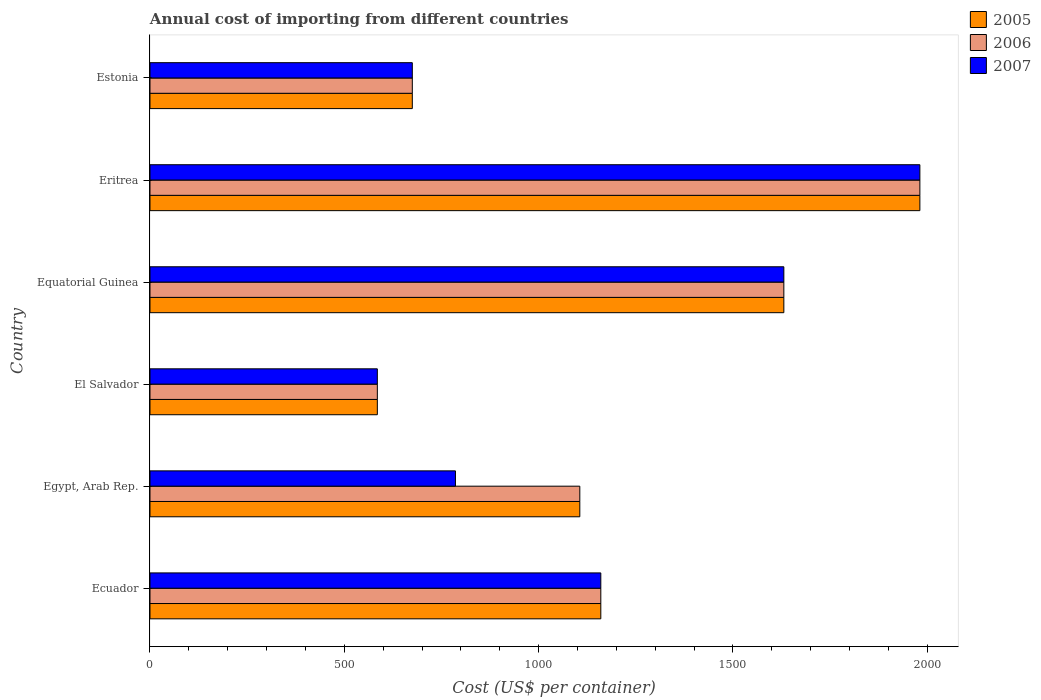How many groups of bars are there?
Give a very brief answer. 6. Are the number of bars per tick equal to the number of legend labels?
Give a very brief answer. Yes. Are the number of bars on each tick of the Y-axis equal?
Make the answer very short. Yes. What is the label of the 2nd group of bars from the top?
Your response must be concise. Eritrea. What is the total annual cost of importing in 2007 in Ecuador?
Ensure brevity in your answer.  1160. Across all countries, what is the maximum total annual cost of importing in 2006?
Your answer should be compact. 1981. Across all countries, what is the minimum total annual cost of importing in 2007?
Make the answer very short. 585. In which country was the total annual cost of importing in 2007 maximum?
Provide a succinct answer. Eritrea. In which country was the total annual cost of importing in 2006 minimum?
Keep it short and to the point. El Salvador. What is the total total annual cost of importing in 2006 in the graph?
Your answer should be very brief. 7138. What is the difference between the total annual cost of importing in 2005 in Ecuador and that in Equatorial Guinea?
Your answer should be very brief. -471. What is the difference between the total annual cost of importing in 2005 in El Salvador and the total annual cost of importing in 2006 in Eritrea?
Offer a terse response. -1396. What is the average total annual cost of importing in 2005 per country?
Your answer should be very brief. 1189.67. What is the difference between the total annual cost of importing in 2006 and total annual cost of importing in 2005 in Estonia?
Keep it short and to the point. 0. What is the ratio of the total annual cost of importing in 2007 in Equatorial Guinea to that in Estonia?
Provide a succinct answer. 2.42. What is the difference between the highest and the second highest total annual cost of importing in 2005?
Offer a terse response. 350. What is the difference between the highest and the lowest total annual cost of importing in 2005?
Provide a succinct answer. 1396. Is the sum of the total annual cost of importing in 2005 in El Salvador and Estonia greater than the maximum total annual cost of importing in 2006 across all countries?
Offer a very short reply. No. What does the 2nd bar from the top in Equatorial Guinea represents?
Provide a succinct answer. 2006. How many bars are there?
Provide a succinct answer. 18. Are all the bars in the graph horizontal?
Make the answer very short. Yes. What is the difference between two consecutive major ticks on the X-axis?
Make the answer very short. 500. Are the values on the major ticks of X-axis written in scientific E-notation?
Your response must be concise. No. Does the graph contain any zero values?
Make the answer very short. No. Does the graph contain grids?
Give a very brief answer. No. How many legend labels are there?
Offer a terse response. 3. How are the legend labels stacked?
Make the answer very short. Vertical. What is the title of the graph?
Keep it short and to the point. Annual cost of importing from different countries. Does "1964" appear as one of the legend labels in the graph?
Provide a short and direct response. No. What is the label or title of the X-axis?
Your answer should be compact. Cost (US$ per container). What is the Cost (US$ per container) in 2005 in Ecuador?
Offer a very short reply. 1160. What is the Cost (US$ per container) of 2006 in Ecuador?
Provide a succinct answer. 1160. What is the Cost (US$ per container) in 2007 in Ecuador?
Give a very brief answer. 1160. What is the Cost (US$ per container) in 2005 in Egypt, Arab Rep.?
Your answer should be very brief. 1106. What is the Cost (US$ per container) in 2006 in Egypt, Arab Rep.?
Offer a very short reply. 1106. What is the Cost (US$ per container) of 2007 in Egypt, Arab Rep.?
Give a very brief answer. 786. What is the Cost (US$ per container) in 2005 in El Salvador?
Your answer should be very brief. 585. What is the Cost (US$ per container) in 2006 in El Salvador?
Your response must be concise. 585. What is the Cost (US$ per container) in 2007 in El Salvador?
Offer a very short reply. 585. What is the Cost (US$ per container) of 2005 in Equatorial Guinea?
Your answer should be very brief. 1631. What is the Cost (US$ per container) of 2006 in Equatorial Guinea?
Provide a short and direct response. 1631. What is the Cost (US$ per container) in 2007 in Equatorial Guinea?
Offer a terse response. 1631. What is the Cost (US$ per container) of 2005 in Eritrea?
Offer a very short reply. 1981. What is the Cost (US$ per container) of 2006 in Eritrea?
Your answer should be very brief. 1981. What is the Cost (US$ per container) of 2007 in Eritrea?
Keep it short and to the point. 1981. What is the Cost (US$ per container) in 2005 in Estonia?
Offer a very short reply. 675. What is the Cost (US$ per container) of 2006 in Estonia?
Your answer should be very brief. 675. What is the Cost (US$ per container) of 2007 in Estonia?
Offer a terse response. 675. Across all countries, what is the maximum Cost (US$ per container) in 2005?
Offer a very short reply. 1981. Across all countries, what is the maximum Cost (US$ per container) of 2006?
Offer a very short reply. 1981. Across all countries, what is the maximum Cost (US$ per container) of 2007?
Ensure brevity in your answer.  1981. Across all countries, what is the minimum Cost (US$ per container) in 2005?
Provide a succinct answer. 585. Across all countries, what is the minimum Cost (US$ per container) in 2006?
Your answer should be compact. 585. Across all countries, what is the minimum Cost (US$ per container) of 2007?
Provide a succinct answer. 585. What is the total Cost (US$ per container) of 2005 in the graph?
Provide a succinct answer. 7138. What is the total Cost (US$ per container) in 2006 in the graph?
Your response must be concise. 7138. What is the total Cost (US$ per container) in 2007 in the graph?
Your response must be concise. 6818. What is the difference between the Cost (US$ per container) of 2005 in Ecuador and that in Egypt, Arab Rep.?
Your response must be concise. 54. What is the difference between the Cost (US$ per container) in 2006 in Ecuador and that in Egypt, Arab Rep.?
Make the answer very short. 54. What is the difference between the Cost (US$ per container) of 2007 in Ecuador and that in Egypt, Arab Rep.?
Your response must be concise. 374. What is the difference between the Cost (US$ per container) of 2005 in Ecuador and that in El Salvador?
Provide a short and direct response. 575. What is the difference between the Cost (US$ per container) in 2006 in Ecuador and that in El Salvador?
Offer a very short reply. 575. What is the difference between the Cost (US$ per container) in 2007 in Ecuador and that in El Salvador?
Your answer should be very brief. 575. What is the difference between the Cost (US$ per container) in 2005 in Ecuador and that in Equatorial Guinea?
Your answer should be compact. -471. What is the difference between the Cost (US$ per container) in 2006 in Ecuador and that in Equatorial Guinea?
Provide a short and direct response. -471. What is the difference between the Cost (US$ per container) in 2007 in Ecuador and that in Equatorial Guinea?
Keep it short and to the point. -471. What is the difference between the Cost (US$ per container) in 2005 in Ecuador and that in Eritrea?
Your response must be concise. -821. What is the difference between the Cost (US$ per container) in 2006 in Ecuador and that in Eritrea?
Your answer should be compact. -821. What is the difference between the Cost (US$ per container) of 2007 in Ecuador and that in Eritrea?
Your answer should be very brief. -821. What is the difference between the Cost (US$ per container) in 2005 in Ecuador and that in Estonia?
Offer a very short reply. 485. What is the difference between the Cost (US$ per container) in 2006 in Ecuador and that in Estonia?
Give a very brief answer. 485. What is the difference between the Cost (US$ per container) in 2007 in Ecuador and that in Estonia?
Provide a short and direct response. 485. What is the difference between the Cost (US$ per container) of 2005 in Egypt, Arab Rep. and that in El Salvador?
Give a very brief answer. 521. What is the difference between the Cost (US$ per container) in 2006 in Egypt, Arab Rep. and that in El Salvador?
Offer a terse response. 521. What is the difference between the Cost (US$ per container) of 2007 in Egypt, Arab Rep. and that in El Salvador?
Ensure brevity in your answer.  201. What is the difference between the Cost (US$ per container) of 2005 in Egypt, Arab Rep. and that in Equatorial Guinea?
Make the answer very short. -525. What is the difference between the Cost (US$ per container) in 2006 in Egypt, Arab Rep. and that in Equatorial Guinea?
Offer a very short reply. -525. What is the difference between the Cost (US$ per container) of 2007 in Egypt, Arab Rep. and that in Equatorial Guinea?
Your answer should be very brief. -845. What is the difference between the Cost (US$ per container) in 2005 in Egypt, Arab Rep. and that in Eritrea?
Ensure brevity in your answer.  -875. What is the difference between the Cost (US$ per container) in 2006 in Egypt, Arab Rep. and that in Eritrea?
Your answer should be very brief. -875. What is the difference between the Cost (US$ per container) in 2007 in Egypt, Arab Rep. and that in Eritrea?
Your answer should be very brief. -1195. What is the difference between the Cost (US$ per container) of 2005 in Egypt, Arab Rep. and that in Estonia?
Your response must be concise. 431. What is the difference between the Cost (US$ per container) of 2006 in Egypt, Arab Rep. and that in Estonia?
Your answer should be compact. 431. What is the difference between the Cost (US$ per container) of 2007 in Egypt, Arab Rep. and that in Estonia?
Make the answer very short. 111. What is the difference between the Cost (US$ per container) of 2005 in El Salvador and that in Equatorial Guinea?
Give a very brief answer. -1046. What is the difference between the Cost (US$ per container) in 2006 in El Salvador and that in Equatorial Guinea?
Your response must be concise. -1046. What is the difference between the Cost (US$ per container) in 2007 in El Salvador and that in Equatorial Guinea?
Make the answer very short. -1046. What is the difference between the Cost (US$ per container) in 2005 in El Salvador and that in Eritrea?
Provide a short and direct response. -1396. What is the difference between the Cost (US$ per container) in 2006 in El Salvador and that in Eritrea?
Give a very brief answer. -1396. What is the difference between the Cost (US$ per container) in 2007 in El Salvador and that in Eritrea?
Make the answer very short. -1396. What is the difference between the Cost (US$ per container) of 2005 in El Salvador and that in Estonia?
Your answer should be compact. -90. What is the difference between the Cost (US$ per container) in 2006 in El Salvador and that in Estonia?
Ensure brevity in your answer.  -90. What is the difference between the Cost (US$ per container) of 2007 in El Salvador and that in Estonia?
Your response must be concise. -90. What is the difference between the Cost (US$ per container) of 2005 in Equatorial Guinea and that in Eritrea?
Provide a short and direct response. -350. What is the difference between the Cost (US$ per container) of 2006 in Equatorial Guinea and that in Eritrea?
Ensure brevity in your answer.  -350. What is the difference between the Cost (US$ per container) in 2007 in Equatorial Guinea and that in Eritrea?
Keep it short and to the point. -350. What is the difference between the Cost (US$ per container) in 2005 in Equatorial Guinea and that in Estonia?
Your answer should be very brief. 956. What is the difference between the Cost (US$ per container) in 2006 in Equatorial Guinea and that in Estonia?
Make the answer very short. 956. What is the difference between the Cost (US$ per container) in 2007 in Equatorial Guinea and that in Estonia?
Your response must be concise. 956. What is the difference between the Cost (US$ per container) of 2005 in Eritrea and that in Estonia?
Your answer should be very brief. 1306. What is the difference between the Cost (US$ per container) in 2006 in Eritrea and that in Estonia?
Offer a very short reply. 1306. What is the difference between the Cost (US$ per container) of 2007 in Eritrea and that in Estonia?
Make the answer very short. 1306. What is the difference between the Cost (US$ per container) in 2005 in Ecuador and the Cost (US$ per container) in 2007 in Egypt, Arab Rep.?
Your answer should be very brief. 374. What is the difference between the Cost (US$ per container) in 2006 in Ecuador and the Cost (US$ per container) in 2007 in Egypt, Arab Rep.?
Your response must be concise. 374. What is the difference between the Cost (US$ per container) in 2005 in Ecuador and the Cost (US$ per container) in 2006 in El Salvador?
Your response must be concise. 575. What is the difference between the Cost (US$ per container) of 2005 in Ecuador and the Cost (US$ per container) of 2007 in El Salvador?
Offer a very short reply. 575. What is the difference between the Cost (US$ per container) of 2006 in Ecuador and the Cost (US$ per container) of 2007 in El Salvador?
Offer a very short reply. 575. What is the difference between the Cost (US$ per container) in 2005 in Ecuador and the Cost (US$ per container) in 2006 in Equatorial Guinea?
Keep it short and to the point. -471. What is the difference between the Cost (US$ per container) in 2005 in Ecuador and the Cost (US$ per container) in 2007 in Equatorial Guinea?
Provide a succinct answer. -471. What is the difference between the Cost (US$ per container) in 2006 in Ecuador and the Cost (US$ per container) in 2007 in Equatorial Guinea?
Keep it short and to the point. -471. What is the difference between the Cost (US$ per container) in 2005 in Ecuador and the Cost (US$ per container) in 2006 in Eritrea?
Keep it short and to the point. -821. What is the difference between the Cost (US$ per container) of 2005 in Ecuador and the Cost (US$ per container) of 2007 in Eritrea?
Offer a terse response. -821. What is the difference between the Cost (US$ per container) of 2006 in Ecuador and the Cost (US$ per container) of 2007 in Eritrea?
Provide a short and direct response. -821. What is the difference between the Cost (US$ per container) in 2005 in Ecuador and the Cost (US$ per container) in 2006 in Estonia?
Give a very brief answer. 485. What is the difference between the Cost (US$ per container) of 2005 in Ecuador and the Cost (US$ per container) of 2007 in Estonia?
Make the answer very short. 485. What is the difference between the Cost (US$ per container) in 2006 in Ecuador and the Cost (US$ per container) in 2007 in Estonia?
Give a very brief answer. 485. What is the difference between the Cost (US$ per container) in 2005 in Egypt, Arab Rep. and the Cost (US$ per container) in 2006 in El Salvador?
Offer a very short reply. 521. What is the difference between the Cost (US$ per container) in 2005 in Egypt, Arab Rep. and the Cost (US$ per container) in 2007 in El Salvador?
Offer a very short reply. 521. What is the difference between the Cost (US$ per container) of 2006 in Egypt, Arab Rep. and the Cost (US$ per container) of 2007 in El Salvador?
Your answer should be compact. 521. What is the difference between the Cost (US$ per container) in 2005 in Egypt, Arab Rep. and the Cost (US$ per container) in 2006 in Equatorial Guinea?
Provide a short and direct response. -525. What is the difference between the Cost (US$ per container) of 2005 in Egypt, Arab Rep. and the Cost (US$ per container) of 2007 in Equatorial Guinea?
Your answer should be compact. -525. What is the difference between the Cost (US$ per container) of 2006 in Egypt, Arab Rep. and the Cost (US$ per container) of 2007 in Equatorial Guinea?
Provide a succinct answer. -525. What is the difference between the Cost (US$ per container) of 2005 in Egypt, Arab Rep. and the Cost (US$ per container) of 2006 in Eritrea?
Ensure brevity in your answer.  -875. What is the difference between the Cost (US$ per container) of 2005 in Egypt, Arab Rep. and the Cost (US$ per container) of 2007 in Eritrea?
Offer a very short reply. -875. What is the difference between the Cost (US$ per container) of 2006 in Egypt, Arab Rep. and the Cost (US$ per container) of 2007 in Eritrea?
Ensure brevity in your answer.  -875. What is the difference between the Cost (US$ per container) in 2005 in Egypt, Arab Rep. and the Cost (US$ per container) in 2006 in Estonia?
Provide a succinct answer. 431. What is the difference between the Cost (US$ per container) in 2005 in Egypt, Arab Rep. and the Cost (US$ per container) in 2007 in Estonia?
Keep it short and to the point. 431. What is the difference between the Cost (US$ per container) of 2006 in Egypt, Arab Rep. and the Cost (US$ per container) of 2007 in Estonia?
Your answer should be compact. 431. What is the difference between the Cost (US$ per container) of 2005 in El Salvador and the Cost (US$ per container) of 2006 in Equatorial Guinea?
Your response must be concise. -1046. What is the difference between the Cost (US$ per container) in 2005 in El Salvador and the Cost (US$ per container) in 2007 in Equatorial Guinea?
Provide a short and direct response. -1046. What is the difference between the Cost (US$ per container) in 2006 in El Salvador and the Cost (US$ per container) in 2007 in Equatorial Guinea?
Make the answer very short. -1046. What is the difference between the Cost (US$ per container) of 2005 in El Salvador and the Cost (US$ per container) of 2006 in Eritrea?
Provide a short and direct response. -1396. What is the difference between the Cost (US$ per container) of 2005 in El Salvador and the Cost (US$ per container) of 2007 in Eritrea?
Offer a very short reply. -1396. What is the difference between the Cost (US$ per container) of 2006 in El Salvador and the Cost (US$ per container) of 2007 in Eritrea?
Your response must be concise. -1396. What is the difference between the Cost (US$ per container) of 2005 in El Salvador and the Cost (US$ per container) of 2006 in Estonia?
Your response must be concise. -90. What is the difference between the Cost (US$ per container) of 2005 in El Salvador and the Cost (US$ per container) of 2007 in Estonia?
Ensure brevity in your answer.  -90. What is the difference between the Cost (US$ per container) of 2006 in El Salvador and the Cost (US$ per container) of 2007 in Estonia?
Ensure brevity in your answer.  -90. What is the difference between the Cost (US$ per container) in 2005 in Equatorial Guinea and the Cost (US$ per container) in 2006 in Eritrea?
Provide a succinct answer. -350. What is the difference between the Cost (US$ per container) of 2005 in Equatorial Guinea and the Cost (US$ per container) of 2007 in Eritrea?
Provide a short and direct response. -350. What is the difference between the Cost (US$ per container) of 2006 in Equatorial Guinea and the Cost (US$ per container) of 2007 in Eritrea?
Give a very brief answer. -350. What is the difference between the Cost (US$ per container) of 2005 in Equatorial Guinea and the Cost (US$ per container) of 2006 in Estonia?
Your response must be concise. 956. What is the difference between the Cost (US$ per container) of 2005 in Equatorial Guinea and the Cost (US$ per container) of 2007 in Estonia?
Offer a very short reply. 956. What is the difference between the Cost (US$ per container) in 2006 in Equatorial Guinea and the Cost (US$ per container) in 2007 in Estonia?
Provide a short and direct response. 956. What is the difference between the Cost (US$ per container) in 2005 in Eritrea and the Cost (US$ per container) in 2006 in Estonia?
Provide a succinct answer. 1306. What is the difference between the Cost (US$ per container) of 2005 in Eritrea and the Cost (US$ per container) of 2007 in Estonia?
Give a very brief answer. 1306. What is the difference between the Cost (US$ per container) in 2006 in Eritrea and the Cost (US$ per container) in 2007 in Estonia?
Ensure brevity in your answer.  1306. What is the average Cost (US$ per container) of 2005 per country?
Offer a terse response. 1189.67. What is the average Cost (US$ per container) of 2006 per country?
Your answer should be very brief. 1189.67. What is the average Cost (US$ per container) of 2007 per country?
Ensure brevity in your answer.  1136.33. What is the difference between the Cost (US$ per container) of 2005 and Cost (US$ per container) of 2006 in Ecuador?
Your answer should be very brief. 0. What is the difference between the Cost (US$ per container) of 2005 and Cost (US$ per container) of 2007 in Ecuador?
Offer a terse response. 0. What is the difference between the Cost (US$ per container) in 2006 and Cost (US$ per container) in 2007 in Ecuador?
Your answer should be very brief. 0. What is the difference between the Cost (US$ per container) of 2005 and Cost (US$ per container) of 2006 in Egypt, Arab Rep.?
Your answer should be very brief. 0. What is the difference between the Cost (US$ per container) in 2005 and Cost (US$ per container) in 2007 in Egypt, Arab Rep.?
Provide a succinct answer. 320. What is the difference between the Cost (US$ per container) in 2006 and Cost (US$ per container) in 2007 in Egypt, Arab Rep.?
Make the answer very short. 320. What is the difference between the Cost (US$ per container) of 2006 and Cost (US$ per container) of 2007 in El Salvador?
Make the answer very short. 0. What is the difference between the Cost (US$ per container) in 2006 and Cost (US$ per container) in 2007 in Equatorial Guinea?
Your response must be concise. 0. What is the difference between the Cost (US$ per container) in 2005 and Cost (US$ per container) in 2006 in Eritrea?
Your answer should be compact. 0. What is the difference between the Cost (US$ per container) of 2005 and Cost (US$ per container) of 2007 in Eritrea?
Your answer should be very brief. 0. What is the difference between the Cost (US$ per container) of 2006 and Cost (US$ per container) of 2007 in Eritrea?
Make the answer very short. 0. What is the difference between the Cost (US$ per container) of 2005 and Cost (US$ per container) of 2006 in Estonia?
Provide a short and direct response. 0. What is the difference between the Cost (US$ per container) of 2006 and Cost (US$ per container) of 2007 in Estonia?
Your answer should be compact. 0. What is the ratio of the Cost (US$ per container) of 2005 in Ecuador to that in Egypt, Arab Rep.?
Your answer should be very brief. 1.05. What is the ratio of the Cost (US$ per container) in 2006 in Ecuador to that in Egypt, Arab Rep.?
Give a very brief answer. 1.05. What is the ratio of the Cost (US$ per container) of 2007 in Ecuador to that in Egypt, Arab Rep.?
Make the answer very short. 1.48. What is the ratio of the Cost (US$ per container) of 2005 in Ecuador to that in El Salvador?
Your answer should be compact. 1.98. What is the ratio of the Cost (US$ per container) in 2006 in Ecuador to that in El Salvador?
Your answer should be very brief. 1.98. What is the ratio of the Cost (US$ per container) of 2007 in Ecuador to that in El Salvador?
Make the answer very short. 1.98. What is the ratio of the Cost (US$ per container) of 2005 in Ecuador to that in Equatorial Guinea?
Make the answer very short. 0.71. What is the ratio of the Cost (US$ per container) in 2006 in Ecuador to that in Equatorial Guinea?
Offer a very short reply. 0.71. What is the ratio of the Cost (US$ per container) in 2007 in Ecuador to that in Equatorial Guinea?
Keep it short and to the point. 0.71. What is the ratio of the Cost (US$ per container) of 2005 in Ecuador to that in Eritrea?
Make the answer very short. 0.59. What is the ratio of the Cost (US$ per container) in 2006 in Ecuador to that in Eritrea?
Offer a terse response. 0.59. What is the ratio of the Cost (US$ per container) of 2007 in Ecuador to that in Eritrea?
Keep it short and to the point. 0.59. What is the ratio of the Cost (US$ per container) in 2005 in Ecuador to that in Estonia?
Your answer should be compact. 1.72. What is the ratio of the Cost (US$ per container) of 2006 in Ecuador to that in Estonia?
Keep it short and to the point. 1.72. What is the ratio of the Cost (US$ per container) in 2007 in Ecuador to that in Estonia?
Provide a succinct answer. 1.72. What is the ratio of the Cost (US$ per container) in 2005 in Egypt, Arab Rep. to that in El Salvador?
Your response must be concise. 1.89. What is the ratio of the Cost (US$ per container) in 2006 in Egypt, Arab Rep. to that in El Salvador?
Provide a succinct answer. 1.89. What is the ratio of the Cost (US$ per container) in 2007 in Egypt, Arab Rep. to that in El Salvador?
Provide a succinct answer. 1.34. What is the ratio of the Cost (US$ per container) in 2005 in Egypt, Arab Rep. to that in Equatorial Guinea?
Offer a very short reply. 0.68. What is the ratio of the Cost (US$ per container) of 2006 in Egypt, Arab Rep. to that in Equatorial Guinea?
Provide a succinct answer. 0.68. What is the ratio of the Cost (US$ per container) of 2007 in Egypt, Arab Rep. to that in Equatorial Guinea?
Keep it short and to the point. 0.48. What is the ratio of the Cost (US$ per container) of 2005 in Egypt, Arab Rep. to that in Eritrea?
Your response must be concise. 0.56. What is the ratio of the Cost (US$ per container) in 2006 in Egypt, Arab Rep. to that in Eritrea?
Ensure brevity in your answer.  0.56. What is the ratio of the Cost (US$ per container) in 2007 in Egypt, Arab Rep. to that in Eritrea?
Your answer should be compact. 0.4. What is the ratio of the Cost (US$ per container) in 2005 in Egypt, Arab Rep. to that in Estonia?
Provide a short and direct response. 1.64. What is the ratio of the Cost (US$ per container) in 2006 in Egypt, Arab Rep. to that in Estonia?
Your answer should be compact. 1.64. What is the ratio of the Cost (US$ per container) in 2007 in Egypt, Arab Rep. to that in Estonia?
Make the answer very short. 1.16. What is the ratio of the Cost (US$ per container) of 2005 in El Salvador to that in Equatorial Guinea?
Give a very brief answer. 0.36. What is the ratio of the Cost (US$ per container) in 2006 in El Salvador to that in Equatorial Guinea?
Make the answer very short. 0.36. What is the ratio of the Cost (US$ per container) in 2007 in El Salvador to that in Equatorial Guinea?
Your answer should be very brief. 0.36. What is the ratio of the Cost (US$ per container) of 2005 in El Salvador to that in Eritrea?
Provide a succinct answer. 0.3. What is the ratio of the Cost (US$ per container) of 2006 in El Salvador to that in Eritrea?
Offer a very short reply. 0.3. What is the ratio of the Cost (US$ per container) in 2007 in El Salvador to that in Eritrea?
Provide a short and direct response. 0.3. What is the ratio of the Cost (US$ per container) of 2005 in El Salvador to that in Estonia?
Your answer should be very brief. 0.87. What is the ratio of the Cost (US$ per container) in 2006 in El Salvador to that in Estonia?
Offer a very short reply. 0.87. What is the ratio of the Cost (US$ per container) of 2007 in El Salvador to that in Estonia?
Your answer should be compact. 0.87. What is the ratio of the Cost (US$ per container) of 2005 in Equatorial Guinea to that in Eritrea?
Provide a succinct answer. 0.82. What is the ratio of the Cost (US$ per container) in 2006 in Equatorial Guinea to that in Eritrea?
Keep it short and to the point. 0.82. What is the ratio of the Cost (US$ per container) of 2007 in Equatorial Guinea to that in Eritrea?
Your answer should be very brief. 0.82. What is the ratio of the Cost (US$ per container) of 2005 in Equatorial Guinea to that in Estonia?
Offer a terse response. 2.42. What is the ratio of the Cost (US$ per container) of 2006 in Equatorial Guinea to that in Estonia?
Your response must be concise. 2.42. What is the ratio of the Cost (US$ per container) in 2007 in Equatorial Guinea to that in Estonia?
Your response must be concise. 2.42. What is the ratio of the Cost (US$ per container) of 2005 in Eritrea to that in Estonia?
Offer a very short reply. 2.93. What is the ratio of the Cost (US$ per container) in 2006 in Eritrea to that in Estonia?
Offer a terse response. 2.93. What is the ratio of the Cost (US$ per container) of 2007 in Eritrea to that in Estonia?
Offer a very short reply. 2.93. What is the difference between the highest and the second highest Cost (US$ per container) in 2005?
Ensure brevity in your answer.  350. What is the difference between the highest and the second highest Cost (US$ per container) of 2006?
Provide a succinct answer. 350. What is the difference between the highest and the second highest Cost (US$ per container) of 2007?
Your response must be concise. 350. What is the difference between the highest and the lowest Cost (US$ per container) of 2005?
Your answer should be very brief. 1396. What is the difference between the highest and the lowest Cost (US$ per container) in 2006?
Your answer should be very brief. 1396. What is the difference between the highest and the lowest Cost (US$ per container) in 2007?
Provide a short and direct response. 1396. 